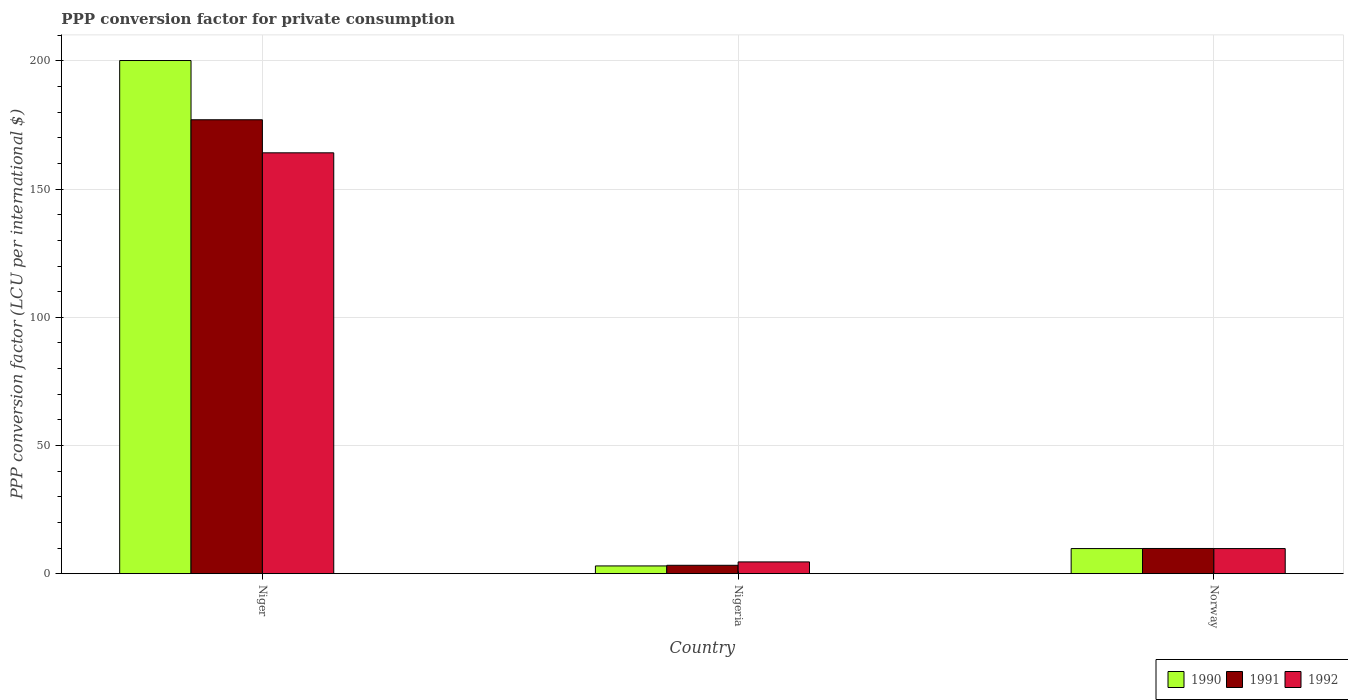How many groups of bars are there?
Offer a very short reply. 3. Are the number of bars per tick equal to the number of legend labels?
Provide a short and direct response. Yes. Are the number of bars on each tick of the X-axis equal?
Provide a short and direct response. Yes. How many bars are there on the 1st tick from the right?
Your answer should be compact. 3. What is the label of the 2nd group of bars from the left?
Your answer should be very brief. Nigeria. What is the PPP conversion factor for private consumption in 1990 in Niger?
Provide a succinct answer. 200.16. Across all countries, what is the maximum PPP conversion factor for private consumption in 1992?
Provide a succinct answer. 164.16. Across all countries, what is the minimum PPP conversion factor for private consumption in 1991?
Ensure brevity in your answer.  3.26. In which country was the PPP conversion factor for private consumption in 1990 maximum?
Provide a short and direct response. Niger. In which country was the PPP conversion factor for private consumption in 1992 minimum?
Provide a short and direct response. Nigeria. What is the total PPP conversion factor for private consumption in 1990 in the graph?
Your answer should be compact. 212.96. What is the difference between the PPP conversion factor for private consumption in 1992 in Nigeria and that in Norway?
Offer a very short reply. -5.21. What is the difference between the PPP conversion factor for private consumption in 1991 in Norway and the PPP conversion factor for private consumption in 1992 in Nigeria?
Offer a very short reply. 5.24. What is the average PPP conversion factor for private consumption in 1990 per country?
Your response must be concise. 70.99. What is the difference between the PPP conversion factor for private consumption of/in 1990 and PPP conversion factor for private consumption of/in 1991 in Niger?
Ensure brevity in your answer.  23.1. What is the ratio of the PPP conversion factor for private consumption in 1990 in Niger to that in Nigeria?
Your response must be concise. 66.52. Is the PPP conversion factor for private consumption in 1991 in Niger less than that in Norway?
Provide a short and direct response. No. Is the difference between the PPP conversion factor for private consumption in 1990 in Niger and Nigeria greater than the difference between the PPP conversion factor for private consumption in 1991 in Niger and Nigeria?
Offer a very short reply. Yes. What is the difference between the highest and the second highest PPP conversion factor for private consumption in 1992?
Offer a terse response. -154.38. What is the difference between the highest and the lowest PPP conversion factor for private consumption in 1991?
Offer a very short reply. 173.79. Is the sum of the PPP conversion factor for private consumption in 1991 in Niger and Norway greater than the maximum PPP conversion factor for private consumption in 1990 across all countries?
Your response must be concise. No. What does the 1st bar from the right in Norway represents?
Offer a terse response. 1992. Is it the case that in every country, the sum of the PPP conversion factor for private consumption in 1992 and PPP conversion factor for private consumption in 1990 is greater than the PPP conversion factor for private consumption in 1991?
Your answer should be very brief. Yes. Are all the bars in the graph horizontal?
Provide a succinct answer. No. Are the values on the major ticks of Y-axis written in scientific E-notation?
Make the answer very short. No. Where does the legend appear in the graph?
Your answer should be compact. Bottom right. How many legend labels are there?
Your answer should be very brief. 3. What is the title of the graph?
Give a very brief answer. PPP conversion factor for private consumption. Does "1966" appear as one of the legend labels in the graph?
Provide a succinct answer. No. What is the label or title of the X-axis?
Keep it short and to the point. Country. What is the label or title of the Y-axis?
Ensure brevity in your answer.  PPP conversion factor (LCU per international $). What is the PPP conversion factor (LCU per international $) of 1990 in Niger?
Provide a succinct answer. 200.16. What is the PPP conversion factor (LCU per international $) in 1991 in Niger?
Provide a succinct answer. 177.06. What is the PPP conversion factor (LCU per international $) in 1992 in Niger?
Ensure brevity in your answer.  164.16. What is the PPP conversion factor (LCU per international $) in 1990 in Nigeria?
Provide a succinct answer. 3.01. What is the PPP conversion factor (LCU per international $) in 1991 in Nigeria?
Make the answer very short. 3.26. What is the PPP conversion factor (LCU per international $) in 1992 in Nigeria?
Keep it short and to the point. 4.58. What is the PPP conversion factor (LCU per international $) in 1990 in Norway?
Make the answer very short. 9.79. What is the PPP conversion factor (LCU per international $) in 1991 in Norway?
Make the answer very short. 9.82. What is the PPP conversion factor (LCU per international $) in 1992 in Norway?
Provide a succinct answer. 9.78. Across all countries, what is the maximum PPP conversion factor (LCU per international $) in 1990?
Your answer should be compact. 200.16. Across all countries, what is the maximum PPP conversion factor (LCU per international $) in 1991?
Your answer should be compact. 177.06. Across all countries, what is the maximum PPP conversion factor (LCU per international $) of 1992?
Your response must be concise. 164.16. Across all countries, what is the minimum PPP conversion factor (LCU per international $) of 1990?
Provide a short and direct response. 3.01. Across all countries, what is the minimum PPP conversion factor (LCU per international $) of 1991?
Make the answer very short. 3.26. Across all countries, what is the minimum PPP conversion factor (LCU per international $) in 1992?
Make the answer very short. 4.58. What is the total PPP conversion factor (LCU per international $) in 1990 in the graph?
Give a very brief answer. 212.96. What is the total PPP conversion factor (LCU per international $) of 1991 in the graph?
Make the answer very short. 190.14. What is the total PPP conversion factor (LCU per international $) in 1992 in the graph?
Offer a very short reply. 178.52. What is the difference between the PPP conversion factor (LCU per international $) in 1990 in Niger and that in Nigeria?
Keep it short and to the point. 197.15. What is the difference between the PPP conversion factor (LCU per international $) of 1991 in Niger and that in Nigeria?
Your answer should be compact. 173.79. What is the difference between the PPP conversion factor (LCU per international $) in 1992 in Niger and that in Nigeria?
Give a very brief answer. 159.58. What is the difference between the PPP conversion factor (LCU per international $) of 1990 in Niger and that in Norway?
Give a very brief answer. 190.38. What is the difference between the PPP conversion factor (LCU per international $) of 1991 in Niger and that in Norway?
Your answer should be compact. 167.24. What is the difference between the PPP conversion factor (LCU per international $) of 1992 in Niger and that in Norway?
Make the answer very short. 154.38. What is the difference between the PPP conversion factor (LCU per international $) of 1990 in Nigeria and that in Norway?
Your response must be concise. -6.78. What is the difference between the PPP conversion factor (LCU per international $) of 1991 in Nigeria and that in Norway?
Offer a terse response. -6.56. What is the difference between the PPP conversion factor (LCU per international $) of 1992 in Nigeria and that in Norway?
Offer a very short reply. -5.21. What is the difference between the PPP conversion factor (LCU per international $) of 1990 in Niger and the PPP conversion factor (LCU per international $) of 1991 in Nigeria?
Your answer should be very brief. 196.9. What is the difference between the PPP conversion factor (LCU per international $) of 1990 in Niger and the PPP conversion factor (LCU per international $) of 1992 in Nigeria?
Your answer should be compact. 195.58. What is the difference between the PPP conversion factor (LCU per international $) of 1991 in Niger and the PPP conversion factor (LCU per international $) of 1992 in Nigeria?
Your answer should be very brief. 172.48. What is the difference between the PPP conversion factor (LCU per international $) in 1990 in Niger and the PPP conversion factor (LCU per international $) in 1991 in Norway?
Offer a terse response. 190.34. What is the difference between the PPP conversion factor (LCU per international $) in 1990 in Niger and the PPP conversion factor (LCU per international $) in 1992 in Norway?
Your answer should be compact. 190.38. What is the difference between the PPP conversion factor (LCU per international $) of 1991 in Niger and the PPP conversion factor (LCU per international $) of 1992 in Norway?
Offer a very short reply. 167.27. What is the difference between the PPP conversion factor (LCU per international $) in 1990 in Nigeria and the PPP conversion factor (LCU per international $) in 1991 in Norway?
Give a very brief answer. -6.81. What is the difference between the PPP conversion factor (LCU per international $) in 1990 in Nigeria and the PPP conversion factor (LCU per international $) in 1992 in Norway?
Give a very brief answer. -6.77. What is the difference between the PPP conversion factor (LCU per international $) of 1991 in Nigeria and the PPP conversion factor (LCU per international $) of 1992 in Norway?
Make the answer very short. -6.52. What is the average PPP conversion factor (LCU per international $) in 1990 per country?
Provide a short and direct response. 70.99. What is the average PPP conversion factor (LCU per international $) in 1991 per country?
Ensure brevity in your answer.  63.38. What is the average PPP conversion factor (LCU per international $) of 1992 per country?
Your response must be concise. 59.51. What is the difference between the PPP conversion factor (LCU per international $) in 1990 and PPP conversion factor (LCU per international $) in 1991 in Niger?
Ensure brevity in your answer.  23.1. What is the difference between the PPP conversion factor (LCU per international $) in 1990 and PPP conversion factor (LCU per international $) in 1992 in Niger?
Offer a terse response. 36. What is the difference between the PPP conversion factor (LCU per international $) in 1991 and PPP conversion factor (LCU per international $) in 1992 in Niger?
Ensure brevity in your answer.  12.9. What is the difference between the PPP conversion factor (LCU per international $) in 1990 and PPP conversion factor (LCU per international $) in 1991 in Nigeria?
Your answer should be compact. -0.25. What is the difference between the PPP conversion factor (LCU per international $) in 1990 and PPP conversion factor (LCU per international $) in 1992 in Nigeria?
Your answer should be very brief. -1.57. What is the difference between the PPP conversion factor (LCU per international $) of 1991 and PPP conversion factor (LCU per international $) of 1992 in Nigeria?
Your answer should be compact. -1.32. What is the difference between the PPP conversion factor (LCU per international $) in 1990 and PPP conversion factor (LCU per international $) in 1991 in Norway?
Give a very brief answer. -0.04. What is the difference between the PPP conversion factor (LCU per international $) of 1990 and PPP conversion factor (LCU per international $) of 1992 in Norway?
Your answer should be compact. 0. What is the difference between the PPP conversion factor (LCU per international $) in 1991 and PPP conversion factor (LCU per international $) in 1992 in Norway?
Make the answer very short. 0.04. What is the ratio of the PPP conversion factor (LCU per international $) in 1990 in Niger to that in Nigeria?
Give a very brief answer. 66.52. What is the ratio of the PPP conversion factor (LCU per international $) of 1991 in Niger to that in Nigeria?
Your answer should be compact. 54.28. What is the ratio of the PPP conversion factor (LCU per international $) of 1992 in Niger to that in Nigeria?
Give a very brief answer. 35.86. What is the ratio of the PPP conversion factor (LCU per international $) in 1990 in Niger to that in Norway?
Your answer should be very brief. 20.46. What is the ratio of the PPP conversion factor (LCU per international $) in 1991 in Niger to that in Norway?
Your answer should be very brief. 18.03. What is the ratio of the PPP conversion factor (LCU per international $) of 1992 in Niger to that in Norway?
Make the answer very short. 16.78. What is the ratio of the PPP conversion factor (LCU per international $) of 1990 in Nigeria to that in Norway?
Give a very brief answer. 0.31. What is the ratio of the PPP conversion factor (LCU per international $) in 1991 in Nigeria to that in Norway?
Keep it short and to the point. 0.33. What is the ratio of the PPP conversion factor (LCU per international $) of 1992 in Nigeria to that in Norway?
Give a very brief answer. 0.47. What is the difference between the highest and the second highest PPP conversion factor (LCU per international $) of 1990?
Your answer should be compact. 190.38. What is the difference between the highest and the second highest PPP conversion factor (LCU per international $) of 1991?
Provide a short and direct response. 167.24. What is the difference between the highest and the second highest PPP conversion factor (LCU per international $) of 1992?
Give a very brief answer. 154.38. What is the difference between the highest and the lowest PPP conversion factor (LCU per international $) of 1990?
Your response must be concise. 197.15. What is the difference between the highest and the lowest PPP conversion factor (LCU per international $) of 1991?
Provide a succinct answer. 173.79. What is the difference between the highest and the lowest PPP conversion factor (LCU per international $) in 1992?
Your answer should be compact. 159.58. 